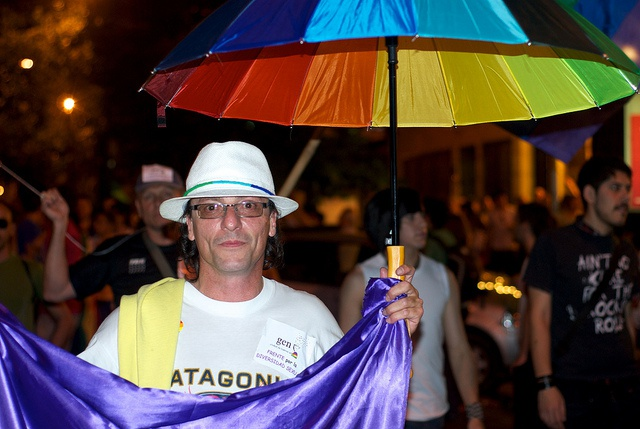Describe the objects in this image and their specific colors. I can see umbrella in black, olive, brown, and maroon tones, people in black, lightgray, khaki, and brown tones, people in black, maroon, gray, and brown tones, people in black, gray, and maroon tones, and people in black, maroon, and brown tones in this image. 